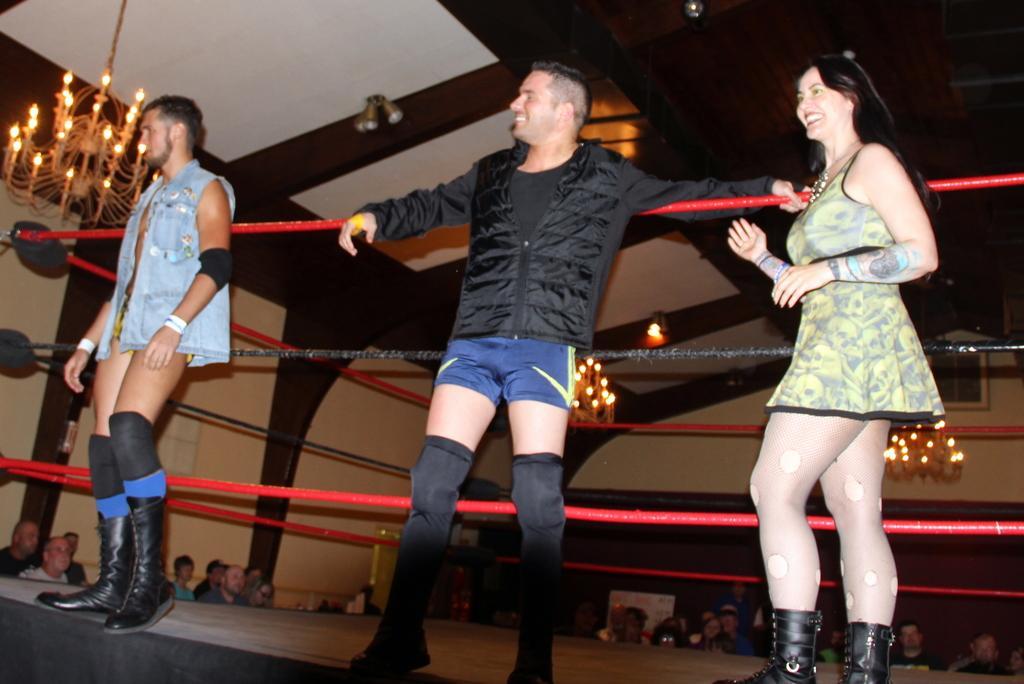In one or two sentences, can you explain what this image depicts? In this image I can see there are three persons standing on stage in front of fence and they are smiling and on the left side I can see a chandelier attached to the roof ,at the bottom in front of stage I can see there are few persons , there are two chandelier visible in the middle, I can see the wall visible in the middle. 